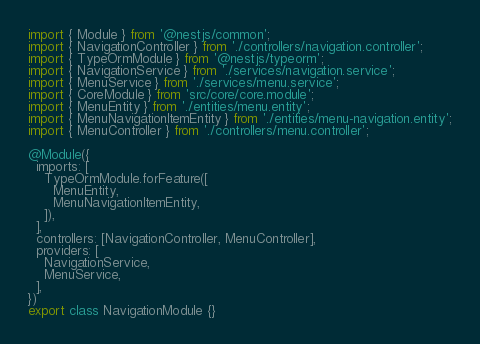<code> <loc_0><loc_0><loc_500><loc_500><_TypeScript_>import { Module } from '@nestjs/common';
import { NavigationController } from './controllers/navigation.controller';
import { TypeOrmModule } from '@nestjs/typeorm';
import { NavigationService } from './services/navigation.service';
import { MenuService } from './services/menu.service';
import { CoreModule } from 'src/core/core.module';
import { MenuEntity } from './entities/menu.entity';
import { MenuNavigationItemEntity } from './entities/menu-navigation.entity';
import { MenuController } from './controllers/menu.controller';

@Module({
  imports: [
    TypeOrmModule.forFeature([
      MenuEntity,
      MenuNavigationItemEntity,
    ]),
  ],
  controllers: [NavigationController, MenuController],
  providers: [
    NavigationService,
    MenuService,
  ],
})
export class NavigationModule {}
</code> 